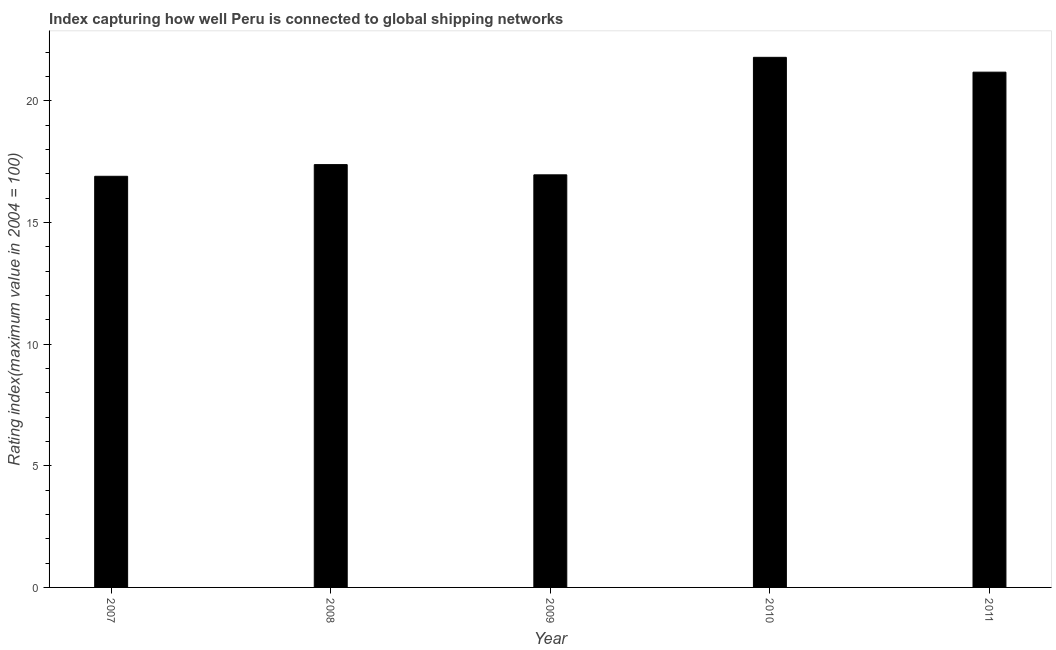Does the graph contain grids?
Offer a terse response. No. What is the title of the graph?
Keep it short and to the point. Index capturing how well Peru is connected to global shipping networks. What is the label or title of the Y-axis?
Offer a very short reply. Rating index(maximum value in 2004 = 100). What is the liner shipping connectivity index in 2009?
Give a very brief answer. 16.96. Across all years, what is the maximum liner shipping connectivity index?
Provide a short and direct response. 21.79. Across all years, what is the minimum liner shipping connectivity index?
Your answer should be compact. 16.9. In which year was the liner shipping connectivity index maximum?
Ensure brevity in your answer.  2010. What is the sum of the liner shipping connectivity index?
Offer a very short reply. 94.21. What is the difference between the liner shipping connectivity index in 2008 and 2009?
Make the answer very short. 0.42. What is the average liner shipping connectivity index per year?
Give a very brief answer. 18.84. What is the median liner shipping connectivity index?
Your answer should be compact. 17.38. In how many years, is the liner shipping connectivity index greater than 17 ?
Provide a short and direct response. 3. Do a majority of the years between 2009 and 2011 (inclusive) have liner shipping connectivity index greater than 20 ?
Your answer should be compact. Yes. What is the ratio of the liner shipping connectivity index in 2008 to that in 2011?
Make the answer very short. 0.82. Is the difference between the liner shipping connectivity index in 2007 and 2009 greater than the difference between any two years?
Keep it short and to the point. No. What is the difference between the highest and the second highest liner shipping connectivity index?
Your answer should be compact. 0.61. What is the difference between the highest and the lowest liner shipping connectivity index?
Give a very brief answer. 4.89. In how many years, is the liner shipping connectivity index greater than the average liner shipping connectivity index taken over all years?
Ensure brevity in your answer.  2. Are all the bars in the graph horizontal?
Provide a succinct answer. No. What is the difference between two consecutive major ticks on the Y-axis?
Give a very brief answer. 5. What is the Rating index(maximum value in 2004 = 100) of 2008?
Ensure brevity in your answer.  17.38. What is the Rating index(maximum value in 2004 = 100) of 2009?
Provide a short and direct response. 16.96. What is the Rating index(maximum value in 2004 = 100) of 2010?
Make the answer very short. 21.79. What is the Rating index(maximum value in 2004 = 100) in 2011?
Make the answer very short. 21.18. What is the difference between the Rating index(maximum value in 2004 = 100) in 2007 and 2008?
Ensure brevity in your answer.  -0.48. What is the difference between the Rating index(maximum value in 2004 = 100) in 2007 and 2009?
Provide a short and direct response. -0.06. What is the difference between the Rating index(maximum value in 2004 = 100) in 2007 and 2010?
Offer a terse response. -4.89. What is the difference between the Rating index(maximum value in 2004 = 100) in 2007 and 2011?
Provide a succinct answer. -4.28. What is the difference between the Rating index(maximum value in 2004 = 100) in 2008 and 2009?
Provide a succinct answer. 0.42. What is the difference between the Rating index(maximum value in 2004 = 100) in 2008 and 2010?
Offer a terse response. -4.41. What is the difference between the Rating index(maximum value in 2004 = 100) in 2008 and 2011?
Keep it short and to the point. -3.8. What is the difference between the Rating index(maximum value in 2004 = 100) in 2009 and 2010?
Your answer should be compact. -4.83. What is the difference between the Rating index(maximum value in 2004 = 100) in 2009 and 2011?
Your response must be concise. -4.22. What is the difference between the Rating index(maximum value in 2004 = 100) in 2010 and 2011?
Keep it short and to the point. 0.61. What is the ratio of the Rating index(maximum value in 2004 = 100) in 2007 to that in 2008?
Your answer should be very brief. 0.97. What is the ratio of the Rating index(maximum value in 2004 = 100) in 2007 to that in 2010?
Your answer should be compact. 0.78. What is the ratio of the Rating index(maximum value in 2004 = 100) in 2007 to that in 2011?
Your response must be concise. 0.8. What is the ratio of the Rating index(maximum value in 2004 = 100) in 2008 to that in 2009?
Provide a succinct answer. 1.02. What is the ratio of the Rating index(maximum value in 2004 = 100) in 2008 to that in 2010?
Make the answer very short. 0.8. What is the ratio of the Rating index(maximum value in 2004 = 100) in 2008 to that in 2011?
Offer a very short reply. 0.82. What is the ratio of the Rating index(maximum value in 2004 = 100) in 2009 to that in 2010?
Give a very brief answer. 0.78. What is the ratio of the Rating index(maximum value in 2004 = 100) in 2009 to that in 2011?
Ensure brevity in your answer.  0.8. 